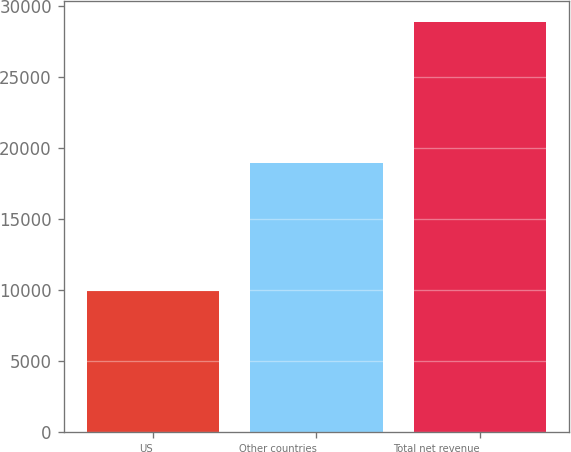<chart> <loc_0><loc_0><loc_500><loc_500><bar_chart><fcel>US<fcel>Other countries<fcel>Total net revenue<nl><fcel>9913<fcel>18958<fcel>28871<nl></chart> 